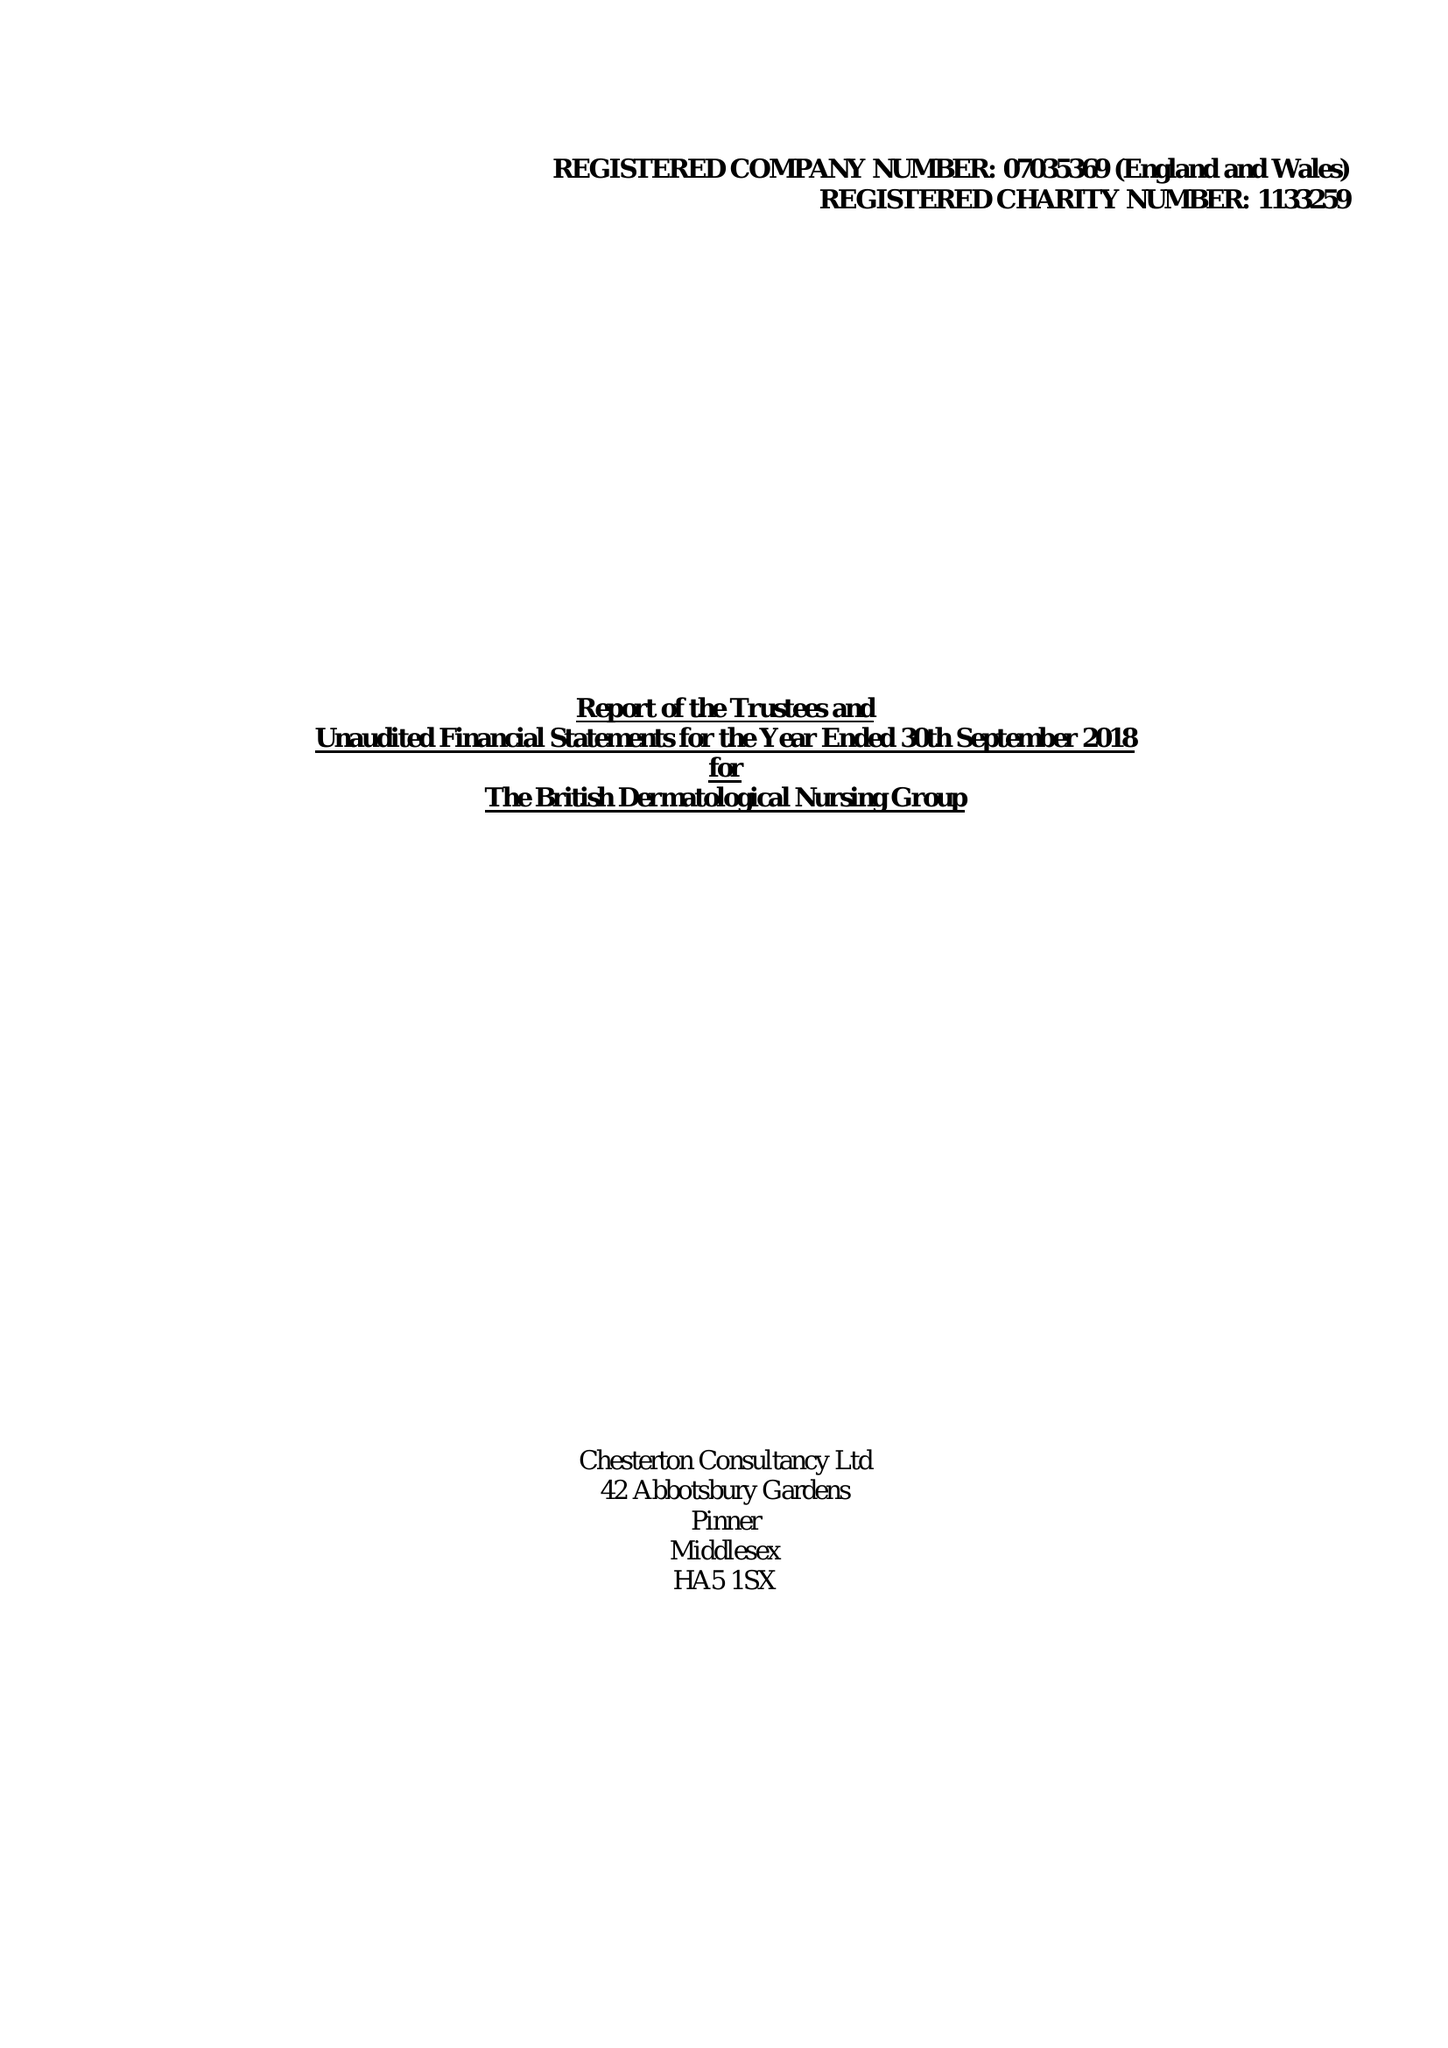What is the value for the address__street_line?
Answer the question using a single word or phrase. 330 HIGH HOLBORN 